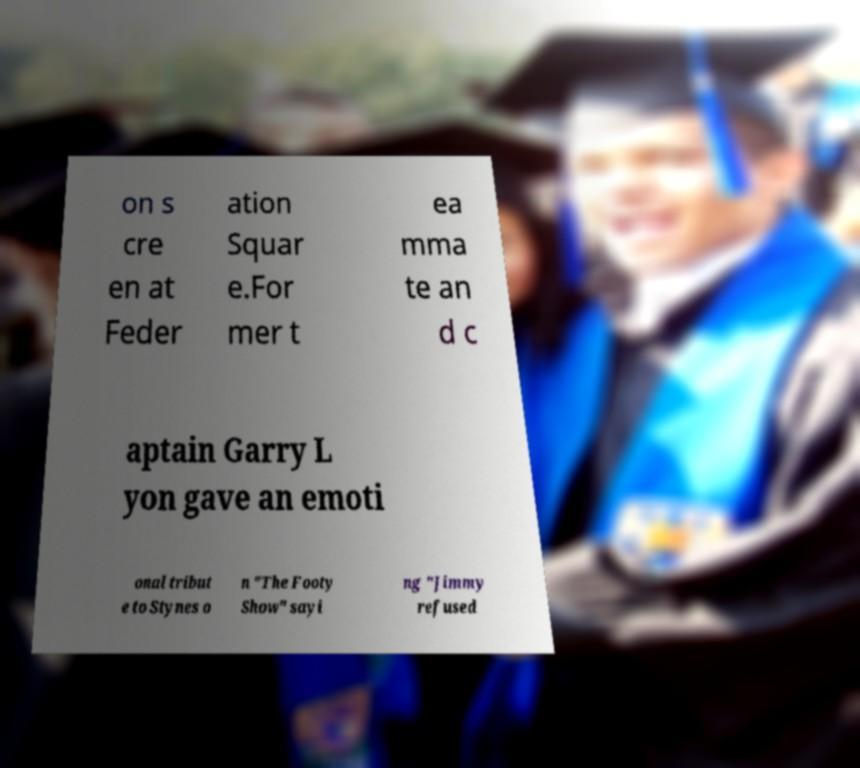Could you extract and type out the text from this image? on s cre en at Feder ation Squar e.For mer t ea mma te an d c aptain Garry L yon gave an emoti onal tribut e to Stynes o n "The Footy Show" sayi ng "Jimmy refused 